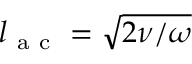Convert formula to latex. <formula><loc_0><loc_0><loc_500><loc_500>l _ { a c } = \sqrt { 2 \nu / \omega }</formula> 